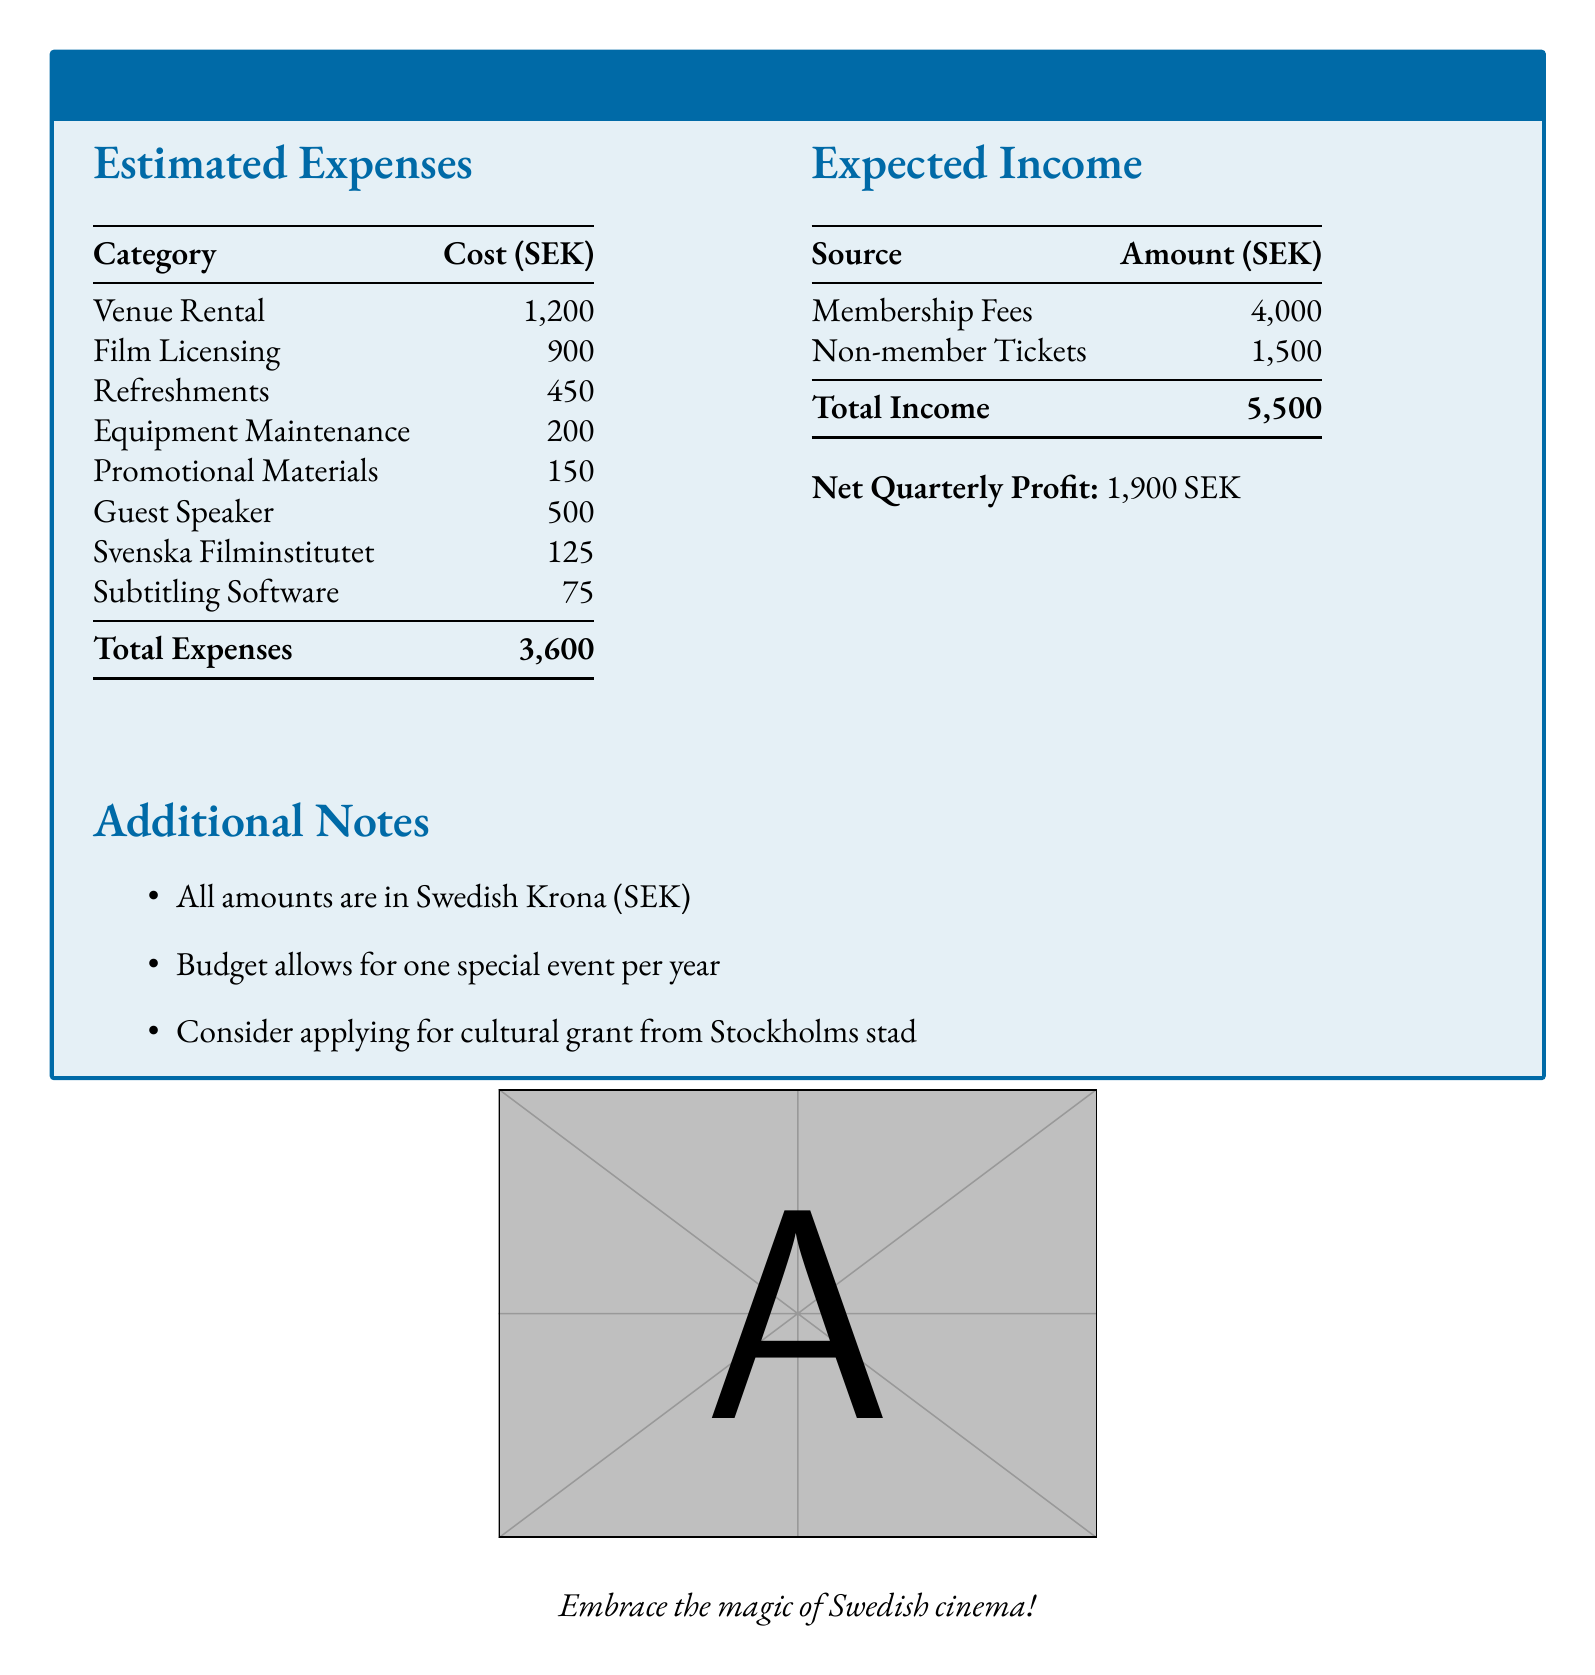What is the total cost of venue rental? The total cost of venue rental is clearly listed in the expenses section of the document.
Answer: 1,200 SEK What is the total expected income? The total expected income is the sum of all income sources provided in the document.
Answer: 5,500 SEK How much is allocated for guest speakers? The allocation for guest speakers is listed as an expense in the document.
Answer: 500 SEK What is the net quarterly profit? The net quarterly profit is calculated as total income minus total expenses, which is specified in the document.
Answer: 1,900 SEK What is included in the additional notes? The additional notes summarize relevant considerations beyond the main budget content.
Answer: Cultural grant application suggestion How much is spent on film licensing? The amount spent on film licensing is indicated in the estimated expenses list.
Answer: 900 SEK What is the cost of the subtitling software? The cost of the subtitling software is found within the estimated expenses section.
Answer: 75 SEK What is the total cost of refreshments? The total cost for refreshments is outlined in the expenses listed in the document.
Answer: 450 SEK What is the cost for promotional materials? The amount allocated for promotional materials is presented in the expenses section.
Answer: 150 SEK 